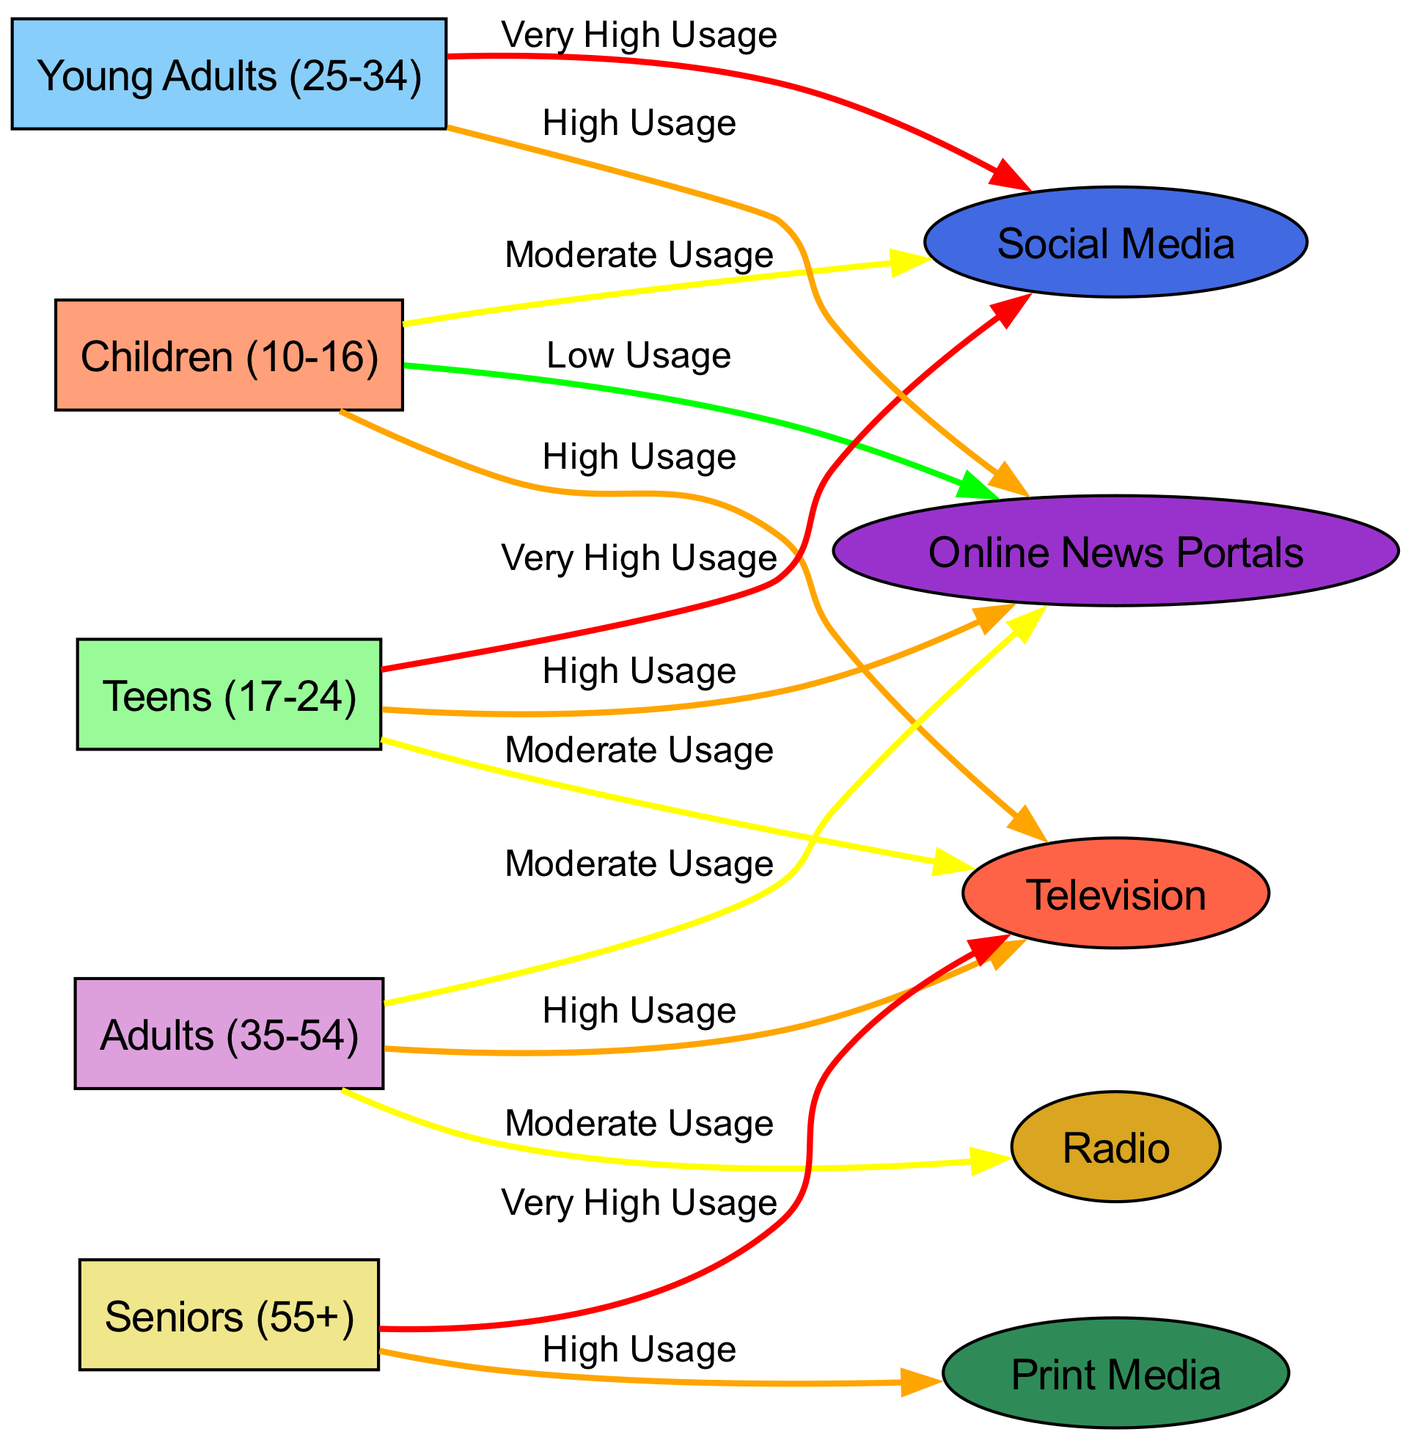What age group has high usage of television? The diagram indicates that both children and adults have a "High Usage" connection to the television node. However, adults have a "Moderate Usage" connection, leading to the answer being the specific age group with only "High Usage."
Answer: Children (10-16) Which medium do seniors use the most? The diagram shows that seniors have "Very High Usage" for television, indicating that this medium is their primary source of media consumption when comparing it with others they use.
Answer: Television How many age groups are represented in the diagram? By counting the nodes specifically allocated for age groups—children, teens, young adults, adults, and seniors—the total comes to five distinct age groups.
Answer: Five What is the predominant media type for teens? The edge from teens to social media indicates "Very High Usage," which shows that teens predominantly use social media compared to other media types.
Answer: Social Media Which group has the least usage of online news portals? The diagram indicates that children have a "Low Usage" connection to online news portals, showing that this group has the least engagement with this medium.
Answer: Children (10-16) What type of media do young adults and teens equally use? Both young adults and teens exhibit "High Usage" of online news portals, indicating they consume this type of media similarly. The connections reveal this shared pattern.
Answer: Online News Portals Which medium do adults use moderately besides television? The edges indicate that adults also have a "Moderate Usage" for both online news and radio. However, since the question asks for another medium aside from television, the answer is directly based on the other connection.
Answer: Radio How does the media consumption of seniors differ from that of children? Seniors demonstrate "Very High Usage" of television and "High Usage" of print media, while children show "High Usage" for television but only "Moderate Usage" for social media and "Low Usage" for online news, indicating a contrast in preferences and consumption levels.
Answer: More varied media types (including print media) 